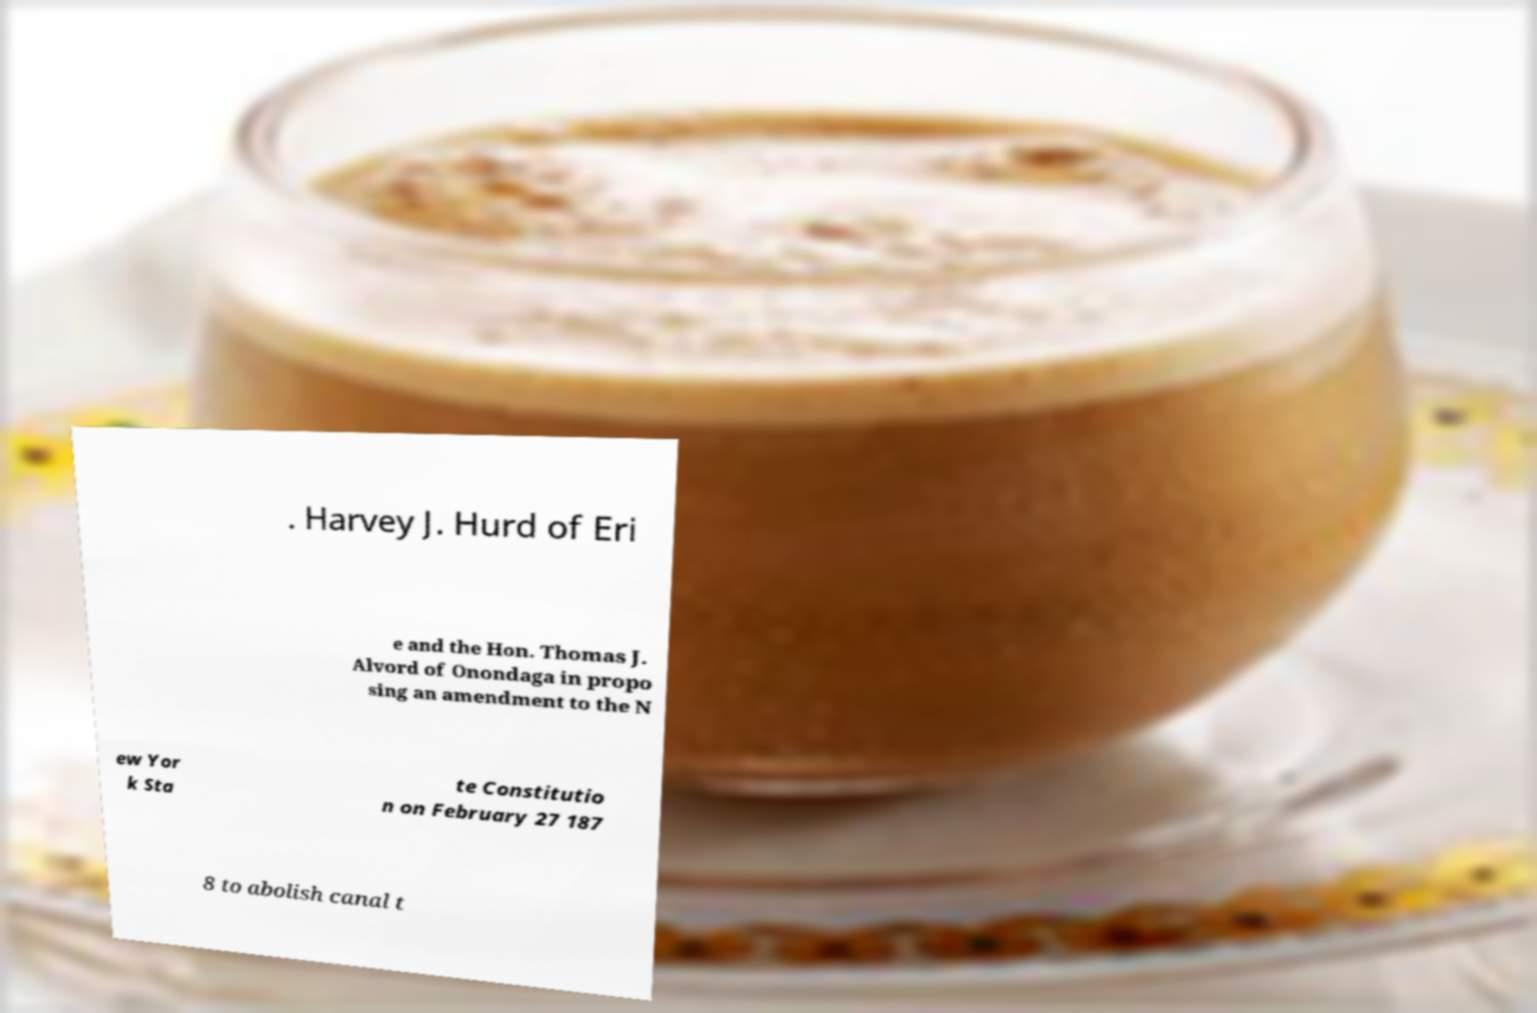Please read and relay the text visible in this image. What does it say? . Harvey J. Hurd of Eri e and the Hon. Thomas J. Alvord of Onondaga in propo sing an amendment to the N ew Yor k Sta te Constitutio n on February 27 187 8 to abolish canal t 